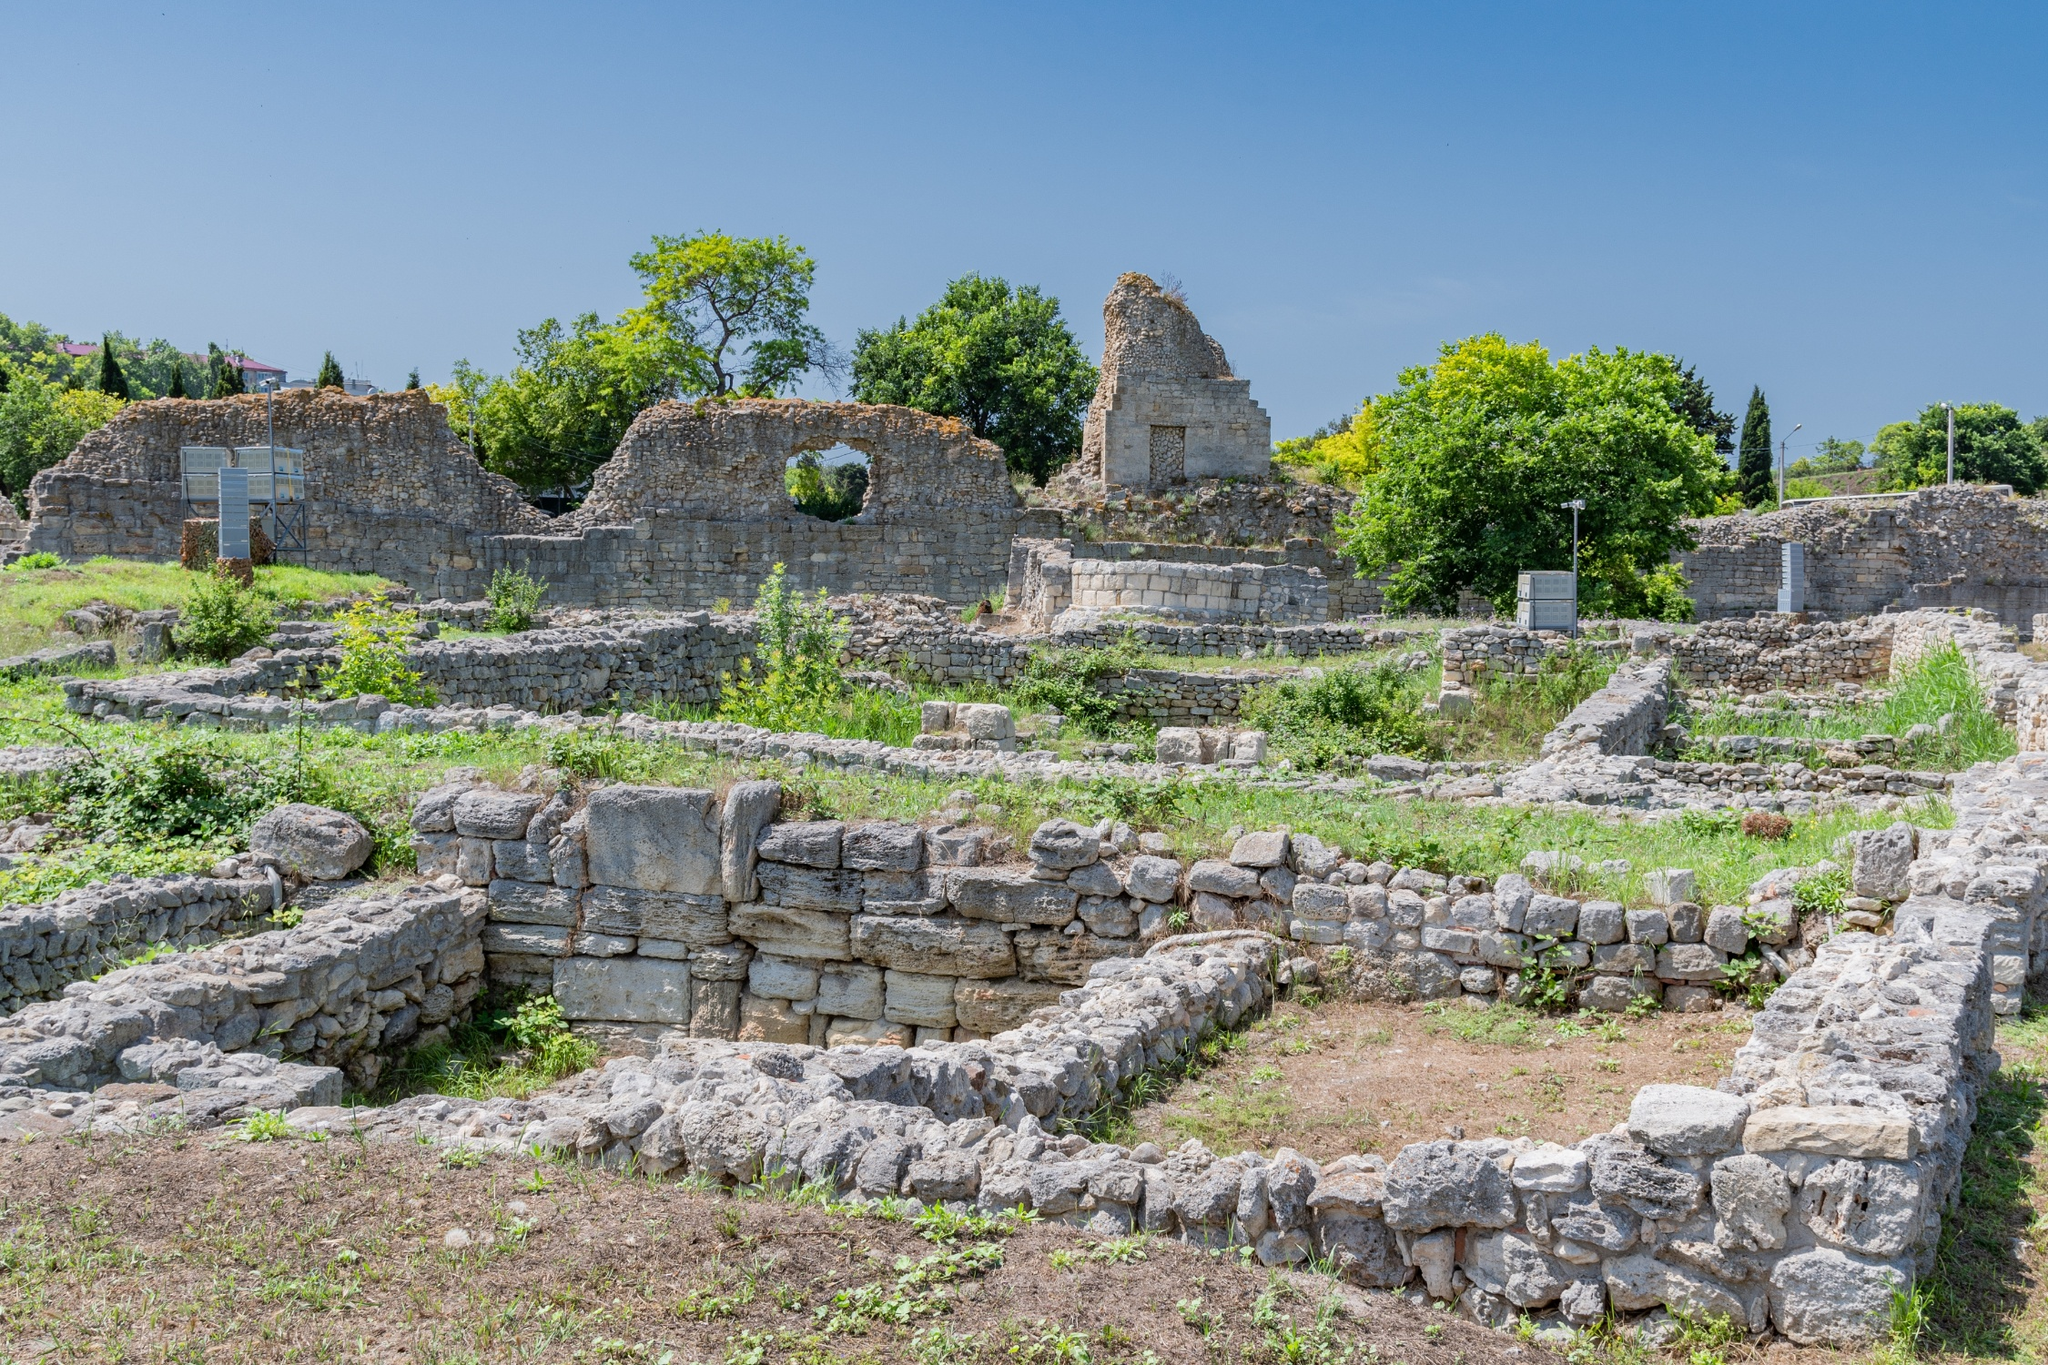In a realistic scenario, what might have led to the fall of this civilization? Several factors could have contributed to the fall of this civilization. Natural disasters such as earthquakes or floods could have caused significant damage to the infrastructure, making it difficult for the society to recover. Additionally, resource depletion might have led to economic decline, causing turmoil and weakening the societal structure. External threats such as invasions or sustained conflict with neighboring civilizations could have resulted in warfare, causing instability and eventual collapse. Internal factors like political corruption, social upheaval, or disease outbreaks could have further exacerbated these challenges, leading to the civilization's eventual downfall.  What modern archaeological methods might be used here? Modern archaeologists would employ a combination of methods to study these ruins. Ground-penetrating radar (GPR) could be used to detect buried structures and artifacts without disturbing the site. Drones equipped with high-resolution cameras would capture detailed aerial images to map and analyze the layout from above. Excavation techniques would be meticulously applied to uncover artifacts, with stratigraphy helping to understand the chronological sequence of building and occupation. Advanced dating methods like radiocarbon dating could determine the age of organic materials, while GIS (Geographic Information Systems) would assist in spatial analysis of the findings. Additionally, 3D modeling and photogrammetry would help create detailed, accurate reconstructions of the site for further study and conservation. 